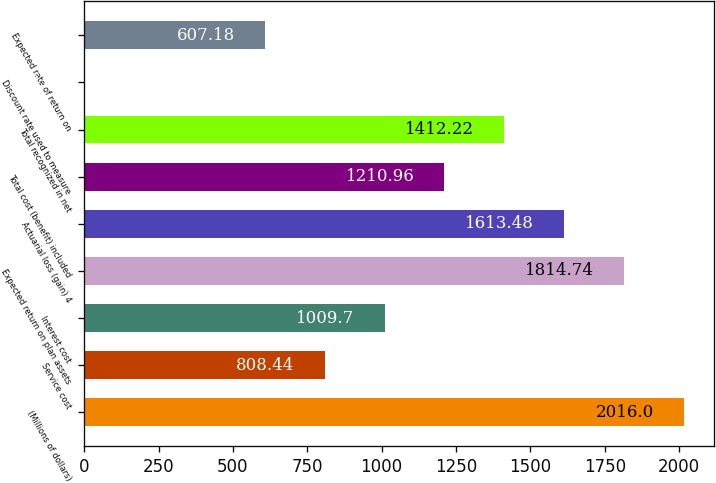<chart> <loc_0><loc_0><loc_500><loc_500><bar_chart><fcel>(Millions of dollars)<fcel>Service cost<fcel>Interest cost<fcel>Expected return on plan assets<fcel>Actuarial loss (gain) 4<fcel>Total cost (benefit) included<fcel>Total recognized in net<fcel>Discount rate used to measure<fcel>Expected rate of return on<nl><fcel>2016<fcel>808.44<fcel>1009.7<fcel>1814.74<fcel>1613.48<fcel>1210.96<fcel>1412.22<fcel>3.4<fcel>607.18<nl></chart> 